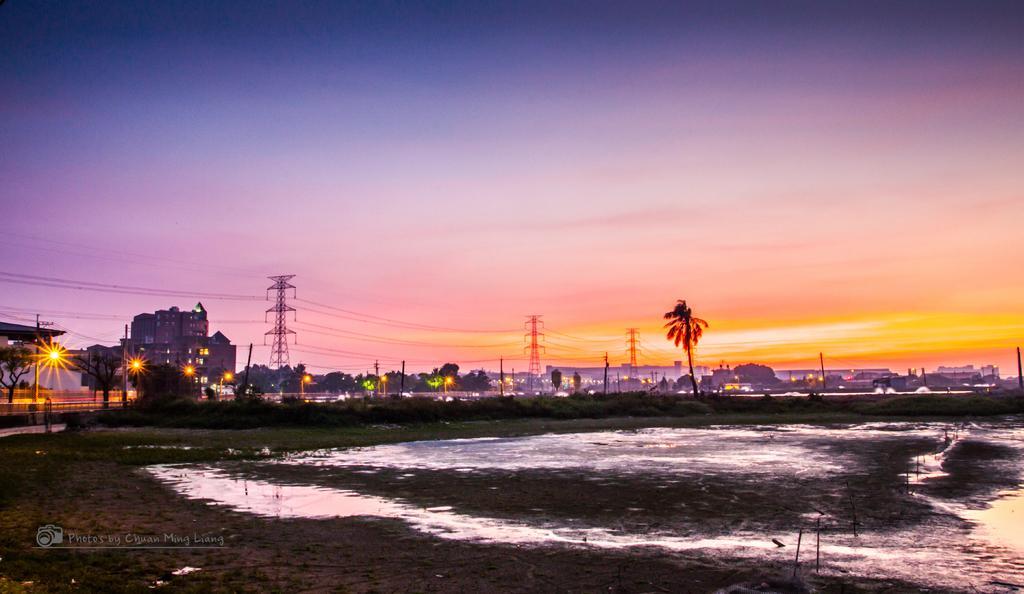Describe this image in one or two sentences. In this picture, I can see trees and few pole lights and I can see towers and buildings and looks like water on the ground and I can see text at the bottom left corner of the picture and I can see sky. 